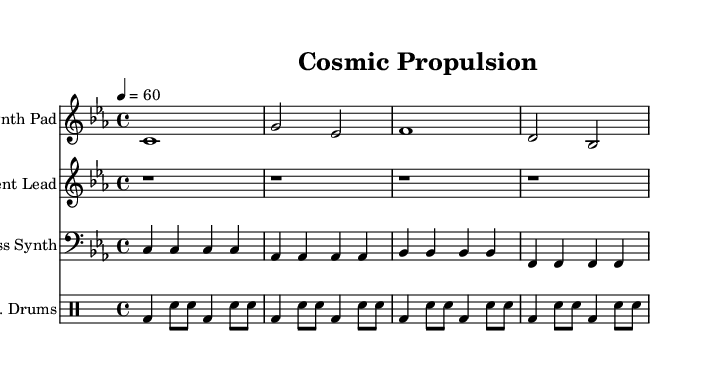What is the key signature of this music? The key signature is C minor, which has three flats: B flat, E flat, and A flat. This is identified by checking the key signature notation at the beginning of the staff.
Answer: C minor What is the time signature of this piece? The time signature is 4/4. This is found in the beginning portion of the sheet music, indicating there are four beats in each measure.
Answer: 4/4 What is the tempo marking for the piece? The tempo indicating 60 beats per minute, given at the beginning, designates the speed at which the music is to be played. This is characterized by the note "4 = 60".
Answer: 60 How many measures are in the main theme? The main theme, as shown, consists of four measures as there are four sets of bar lines that indicate the end of each measure within the staff.
Answer: 4 Which instrument plays the bass line? The bass line is performed by the Bass Synth, indicated by the instrument name written at the beginning of the bass clef staff.
Answer: Bass Synth What does the absence of notes in the ambient lead suggest? The absence of notes during the ambient lead section suggests it is meant to provide a spacious, atmospheric quality, simulating the vastness of space without distinct melodic elements.
Answer: Spacing What rhythmic pattern is used in the drums part? The drums part follows a consistent pattern of bass and snare hits, alternating throughout the measures, creating a steady rhythm typical in electronic ambient music.
Answer: Alternating bass and snare 